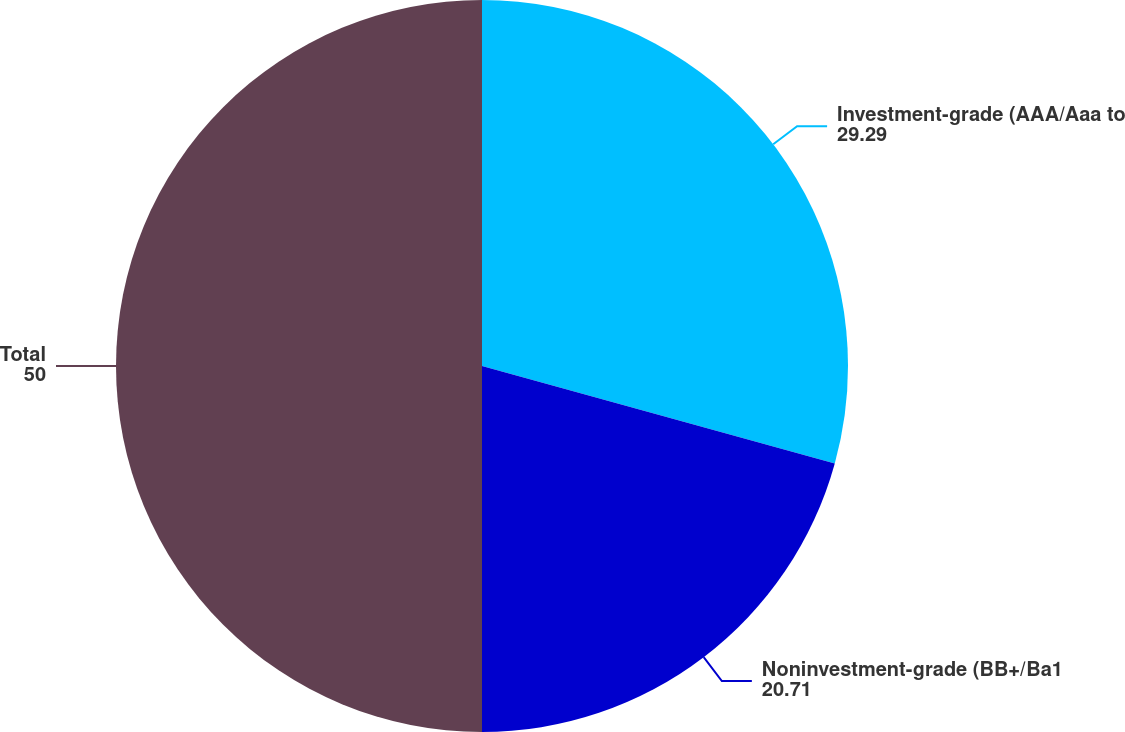Convert chart to OTSL. <chart><loc_0><loc_0><loc_500><loc_500><pie_chart><fcel>Investment-grade (AAA/Aaa to<fcel>Noninvestment-grade (BB+/Ba1<fcel>Total<nl><fcel>29.29%<fcel>20.71%<fcel>50.0%<nl></chart> 